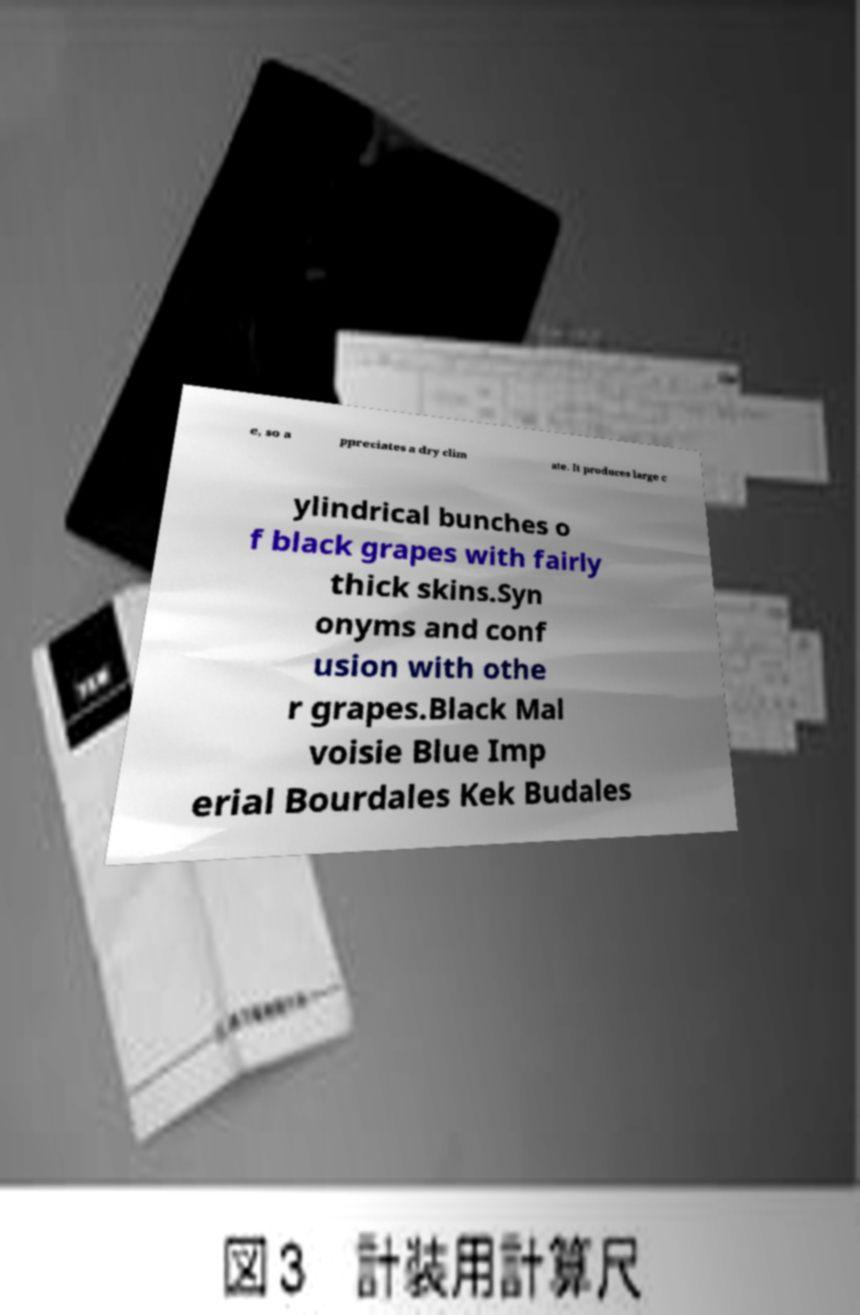Can you accurately transcribe the text from the provided image for me? e, so a ppreciates a dry clim ate. It produces large c ylindrical bunches o f black grapes with fairly thick skins.Syn onyms and conf usion with othe r grapes.Black Mal voisie Blue Imp erial Bourdales Kek Budales 